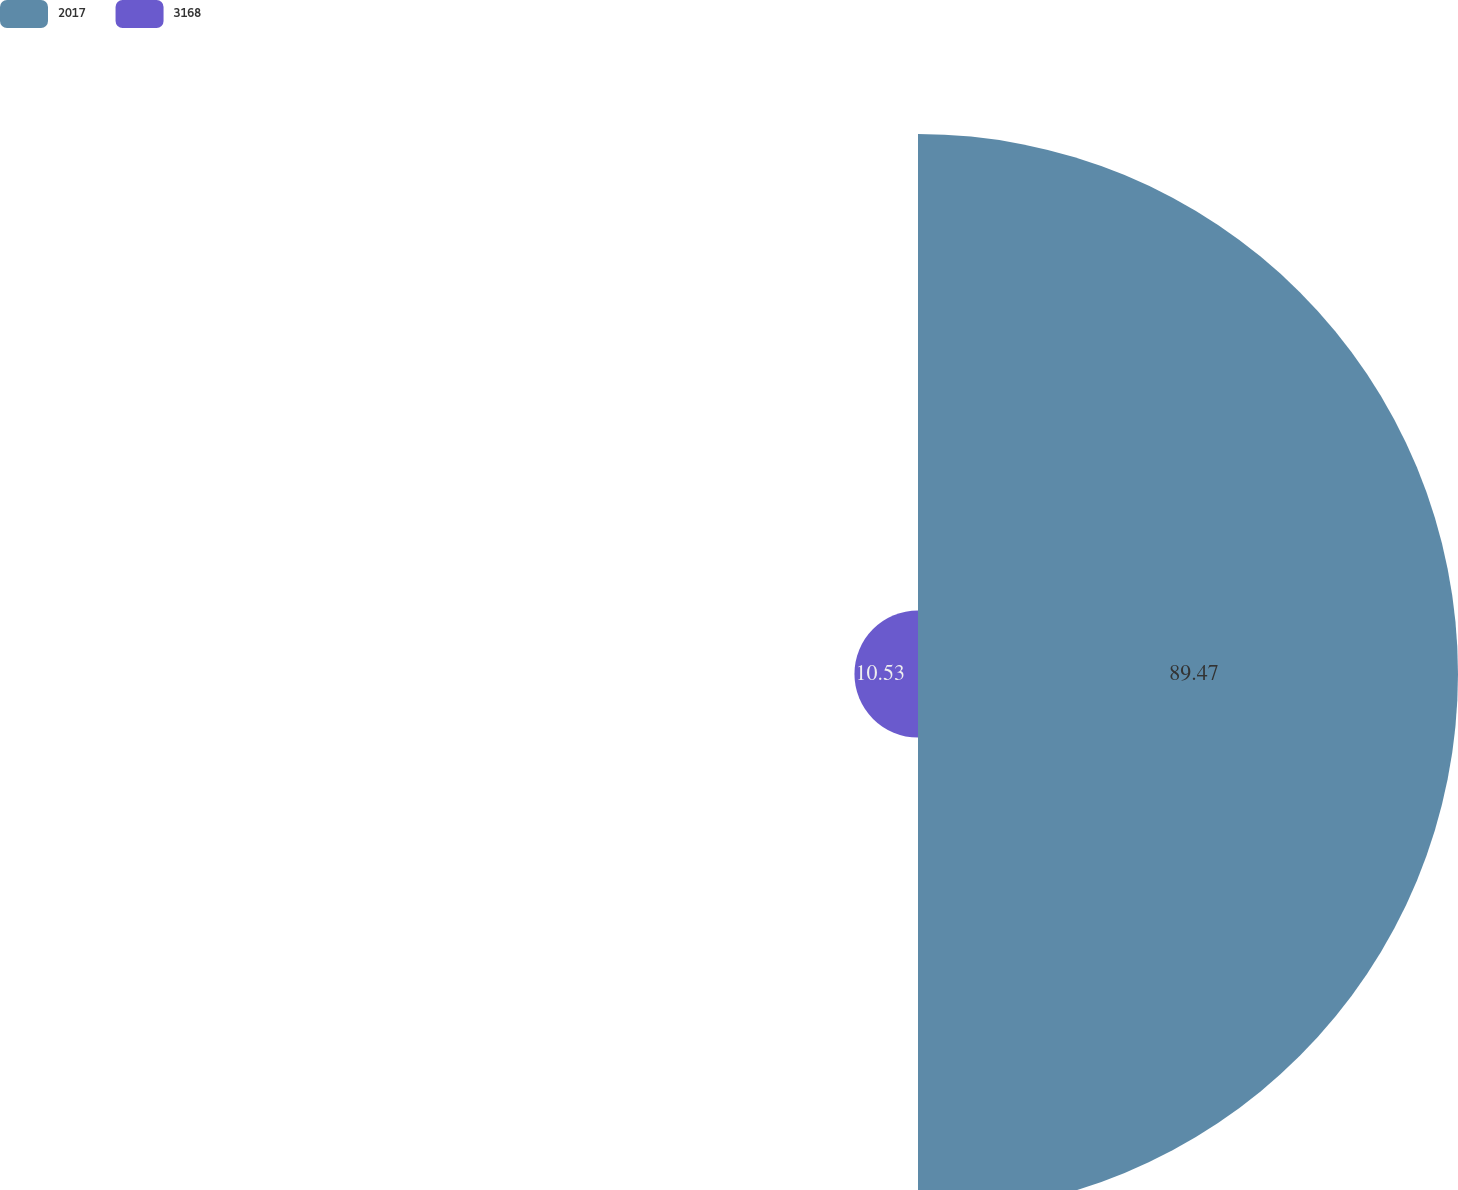Convert chart. <chart><loc_0><loc_0><loc_500><loc_500><pie_chart><fcel>2017<fcel>3168<nl><fcel>89.47%<fcel>10.53%<nl></chart> 